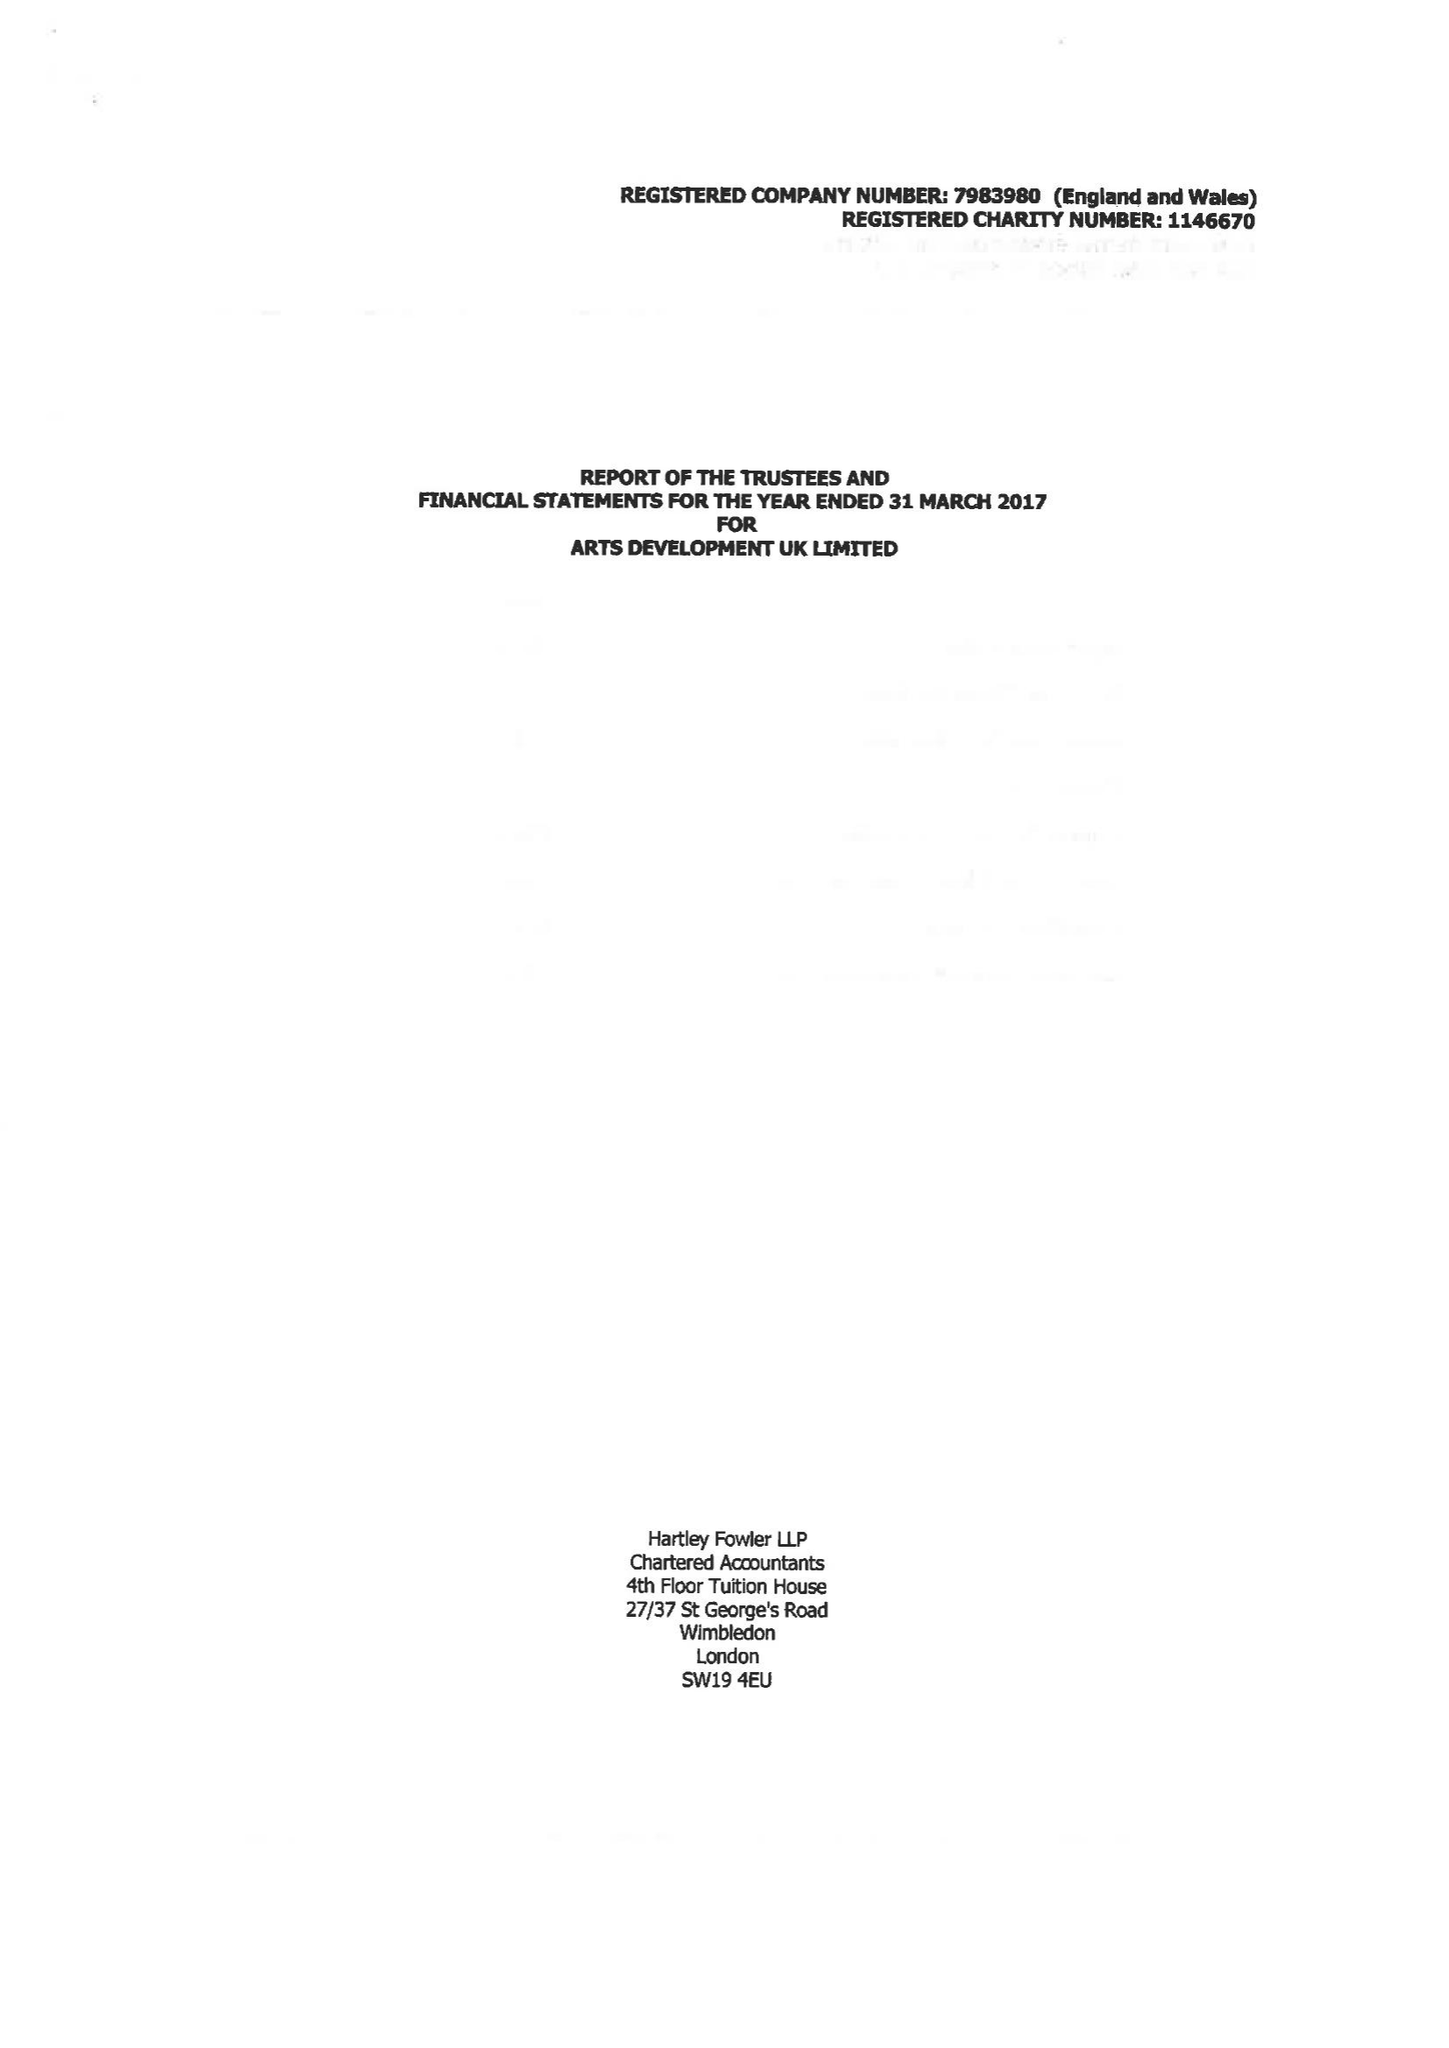What is the value for the address__post_town?
Answer the question using a single word or phrase. AMMANFORD 